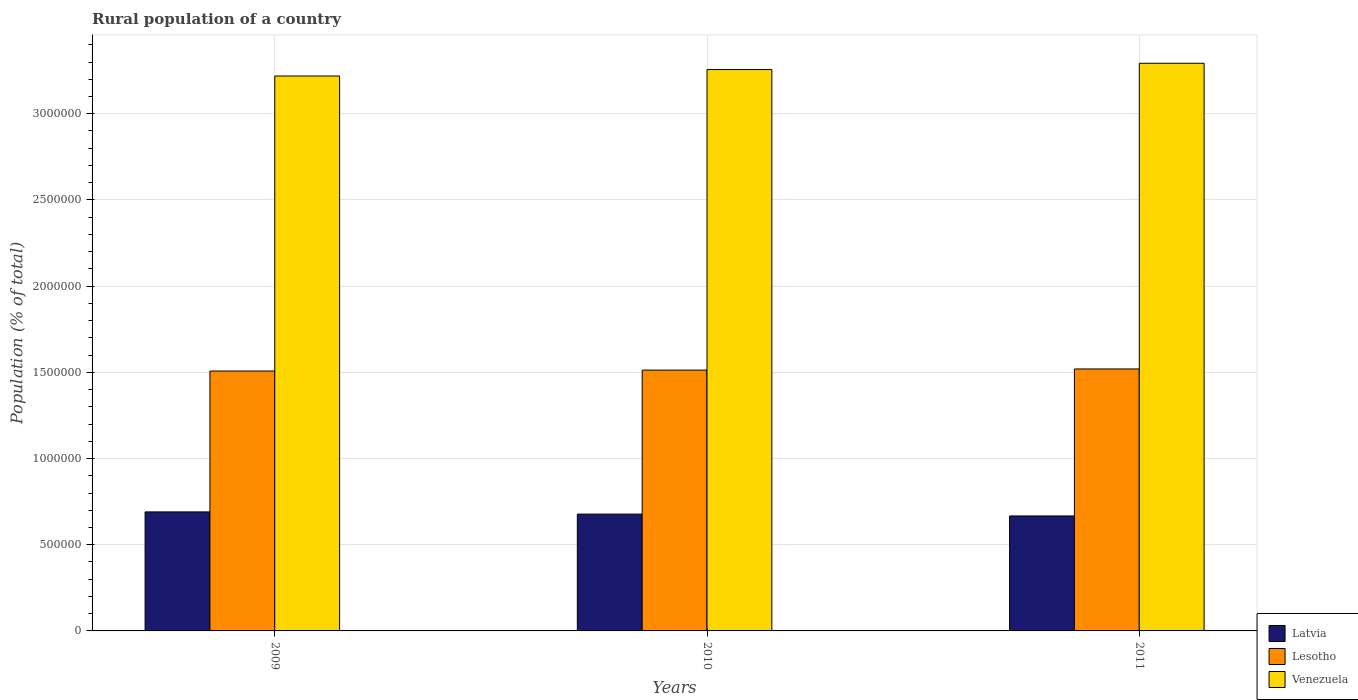How many groups of bars are there?
Offer a terse response. 3. Are the number of bars per tick equal to the number of legend labels?
Provide a short and direct response. Yes. In how many cases, is the number of bars for a given year not equal to the number of legend labels?
Keep it short and to the point. 0. What is the rural population in Lesotho in 2010?
Ensure brevity in your answer.  1.51e+06. Across all years, what is the maximum rural population in Lesotho?
Keep it short and to the point. 1.52e+06. Across all years, what is the minimum rural population in Latvia?
Give a very brief answer. 6.67e+05. In which year was the rural population in Latvia maximum?
Ensure brevity in your answer.  2009. In which year was the rural population in Lesotho minimum?
Provide a short and direct response. 2009. What is the total rural population in Lesotho in the graph?
Keep it short and to the point. 4.54e+06. What is the difference between the rural population in Venezuela in 2010 and that in 2011?
Make the answer very short. -3.64e+04. What is the difference between the rural population in Lesotho in 2011 and the rural population in Latvia in 2010?
Keep it short and to the point. 8.42e+05. What is the average rural population in Venezuela per year?
Offer a terse response. 3.26e+06. In the year 2010, what is the difference between the rural population in Venezuela and rural population in Lesotho?
Your answer should be very brief. 1.74e+06. In how many years, is the rural population in Latvia greater than 2400000 %?
Offer a very short reply. 0. What is the ratio of the rural population in Latvia in 2009 to that in 2010?
Give a very brief answer. 1.02. Is the difference between the rural population in Venezuela in 2009 and 2010 greater than the difference between the rural population in Lesotho in 2009 and 2010?
Your response must be concise. No. What is the difference between the highest and the second highest rural population in Venezuela?
Keep it short and to the point. 3.64e+04. What is the difference between the highest and the lowest rural population in Latvia?
Your answer should be very brief. 2.35e+04. In how many years, is the rural population in Latvia greater than the average rural population in Latvia taken over all years?
Offer a terse response. 1. Is the sum of the rural population in Latvia in 2010 and 2011 greater than the maximum rural population in Lesotho across all years?
Give a very brief answer. No. What does the 3rd bar from the left in 2011 represents?
Offer a terse response. Venezuela. What does the 3rd bar from the right in 2011 represents?
Provide a short and direct response. Latvia. Is it the case that in every year, the sum of the rural population in Lesotho and rural population in Latvia is greater than the rural population in Venezuela?
Ensure brevity in your answer.  No. How many bars are there?
Your answer should be compact. 9. Are all the bars in the graph horizontal?
Your answer should be compact. No. Where does the legend appear in the graph?
Make the answer very short. Bottom right. How many legend labels are there?
Your answer should be compact. 3. How are the legend labels stacked?
Offer a terse response. Vertical. What is the title of the graph?
Offer a very short reply. Rural population of a country. Does "Korea (Republic)" appear as one of the legend labels in the graph?
Your response must be concise. No. What is the label or title of the Y-axis?
Keep it short and to the point. Population (% of total). What is the Population (% of total) of Latvia in 2009?
Provide a short and direct response. 6.90e+05. What is the Population (% of total) in Lesotho in 2009?
Your response must be concise. 1.51e+06. What is the Population (% of total) in Venezuela in 2009?
Ensure brevity in your answer.  3.22e+06. What is the Population (% of total) in Latvia in 2010?
Provide a succinct answer. 6.78e+05. What is the Population (% of total) of Lesotho in 2010?
Your answer should be compact. 1.51e+06. What is the Population (% of total) in Venezuela in 2010?
Keep it short and to the point. 3.26e+06. What is the Population (% of total) in Latvia in 2011?
Ensure brevity in your answer.  6.67e+05. What is the Population (% of total) in Lesotho in 2011?
Give a very brief answer. 1.52e+06. What is the Population (% of total) in Venezuela in 2011?
Offer a terse response. 3.29e+06. Across all years, what is the maximum Population (% of total) in Latvia?
Your answer should be compact. 6.90e+05. Across all years, what is the maximum Population (% of total) in Lesotho?
Give a very brief answer. 1.52e+06. Across all years, what is the maximum Population (% of total) of Venezuela?
Offer a very short reply. 3.29e+06. Across all years, what is the minimum Population (% of total) of Latvia?
Your answer should be very brief. 6.67e+05. Across all years, what is the minimum Population (% of total) in Lesotho?
Your answer should be very brief. 1.51e+06. Across all years, what is the minimum Population (% of total) of Venezuela?
Your answer should be compact. 3.22e+06. What is the total Population (% of total) in Latvia in the graph?
Your answer should be very brief. 2.04e+06. What is the total Population (% of total) in Lesotho in the graph?
Offer a very short reply. 4.54e+06. What is the total Population (% of total) of Venezuela in the graph?
Keep it short and to the point. 9.77e+06. What is the difference between the Population (% of total) in Latvia in 2009 and that in 2010?
Your answer should be very brief. 1.27e+04. What is the difference between the Population (% of total) of Lesotho in 2009 and that in 2010?
Ensure brevity in your answer.  -5347. What is the difference between the Population (% of total) in Venezuela in 2009 and that in 2010?
Your answer should be very brief. -3.74e+04. What is the difference between the Population (% of total) of Latvia in 2009 and that in 2011?
Offer a terse response. 2.35e+04. What is the difference between the Population (% of total) in Lesotho in 2009 and that in 2011?
Your answer should be compact. -1.20e+04. What is the difference between the Population (% of total) of Venezuela in 2009 and that in 2011?
Your answer should be compact. -7.38e+04. What is the difference between the Population (% of total) in Latvia in 2010 and that in 2011?
Your answer should be compact. 1.07e+04. What is the difference between the Population (% of total) in Lesotho in 2010 and that in 2011?
Your response must be concise. -6663. What is the difference between the Population (% of total) of Venezuela in 2010 and that in 2011?
Your answer should be compact. -3.64e+04. What is the difference between the Population (% of total) of Latvia in 2009 and the Population (% of total) of Lesotho in 2010?
Ensure brevity in your answer.  -8.23e+05. What is the difference between the Population (% of total) in Latvia in 2009 and the Population (% of total) in Venezuela in 2010?
Provide a succinct answer. -2.57e+06. What is the difference between the Population (% of total) of Lesotho in 2009 and the Population (% of total) of Venezuela in 2010?
Offer a very short reply. -1.75e+06. What is the difference between the Population (% of total) of Latvia in 2009 and the Population (% of total) of Lesotho in 2011?
Your response must be concise. -8.29e+05. What is the difference between the Population (% of total) of Latvia in 2009 and the Population (% of total) of Venezuela in 2011?
Keep it short and to the point. -2.60e+06. What is the difference between the Population (% of total) of Lesotho in 2009 and the Population (% of total) of Venezuela in 2011?
Make the answer very short. -1.79e+06. What is the difference between the Population (% of total) of Latvia in 2010 and the Population (% of total) of Lesotho in 2011?
Your response must be concise. -8.42e+05. What is the difference between the Population (% of total) in Latvia in 2010 and the Population (% of total) in Venezuela in 2011?
Your response must be concise. -2.62e+06. What is the difference between the Population (% of total) of Lesotho in 2010 and the Population (% of total) of Venezuela in 2011?
Your response must be concise. -1.78e+06. What is the average Population (% of total) in Latvia per year?
Keep it short and to the point. 6.78e+05. What is the average Population (% of total) in Lesotho per year?
Ensure brevity in your answer.  1.51e+06. What is the average Population (% of total) of Venezuela per year?
Offer a very short reply. 3.26e+06. In the year 2009, what is the difference between the Population (% of total) of Latvia and Population (% of total) of Lesotho?
Ensure brevity in your answer.  -8.17e+05. In the year 2009, what is the difference between the Population (% of total) of Latvia and Population (% of total) of Venezuela?
Keep it short and to the point. -2.53e+06. In the year 2009, what is the difference between the Population (% of total) of Lesotho and Population (% of total) of Venezuela?
Provide a succinct answer. -1.71e+06. In the year 2010, what is the difference between the Population (% of total) of Latvia and Population (% of total) of Lesotho?
Your answer should be compact. -8.35e+05. In the year 2010, what is the difference between the Population (% of total) in Latvia and Population (% of total) in Venezuela?
Provide a succinct answer. -2.58e+06. In the year 2010, what is the difference between the Population (% of total) of Lesotho and Population (% of total) of Venezuela?
Ensure brevity in your answer.  -1.74e+06. In the year 2011, what is the difference between the Population (% of total) of Latvia and Population (% of total) of Lesotho?
Keep it short and to the point. -8.53e+05. In the year 2011, what is the difference between the Population (% of total) in Latvia and Population (% of total) in Venezuela?
Provide a succinct answer. -2.63e+06. In the year 2011, what is the difference between the Population (% of total) in Lesotho and Population (% of total) in Venezuela?
Give a very brief answer. -1.77e+06. What is the ratio of the Population (% of total) of Latvia in 2009 to that in 2010?
Provide a short and direct response. 1.02. What is the ratio of the Population (% of total) in Latvia in 2009 to that in 2011?
Ensure brevity in your answer.  1.04. What is the ratio of the Population (% of total) in Venezuela in 2009 to that in 2011?
Provide a short and direct response. 0.98. What is the ratio of the Population (% of total) in Latvia in 2010 to that in 2011?
Offer a very short reply. 1.02. What is the ratio of the Population (% of total) of Venezuela in 2010 to that in 2011?
Your answer should be compact. 0.99. What is the difference between the highest and the second highest Population (% of total) in Latvia?
Keep it short and to the point. 1.27e+04. What is the difference between the highest and the second highest Population (% of total) in Lesotho?
Give a very brief answer. 6663. What is the difference between the highest and the second highest Population (% of total) of Venezuela?
Your answer should be compact. 3.64e+04. What is the difference between the highest and the lowest Population (% of total) in Latvia?
Ensure brevity in your answer.  2.35e+04. What is the difference between the highest and the lowest Population (% of total) of Lesotho?
Provide a succinct answer. 1.20e+04. What is the difference between the highest and the lowest Population (% of total) of Venezuela?
Give a very brief answer. 7.38e+04. 